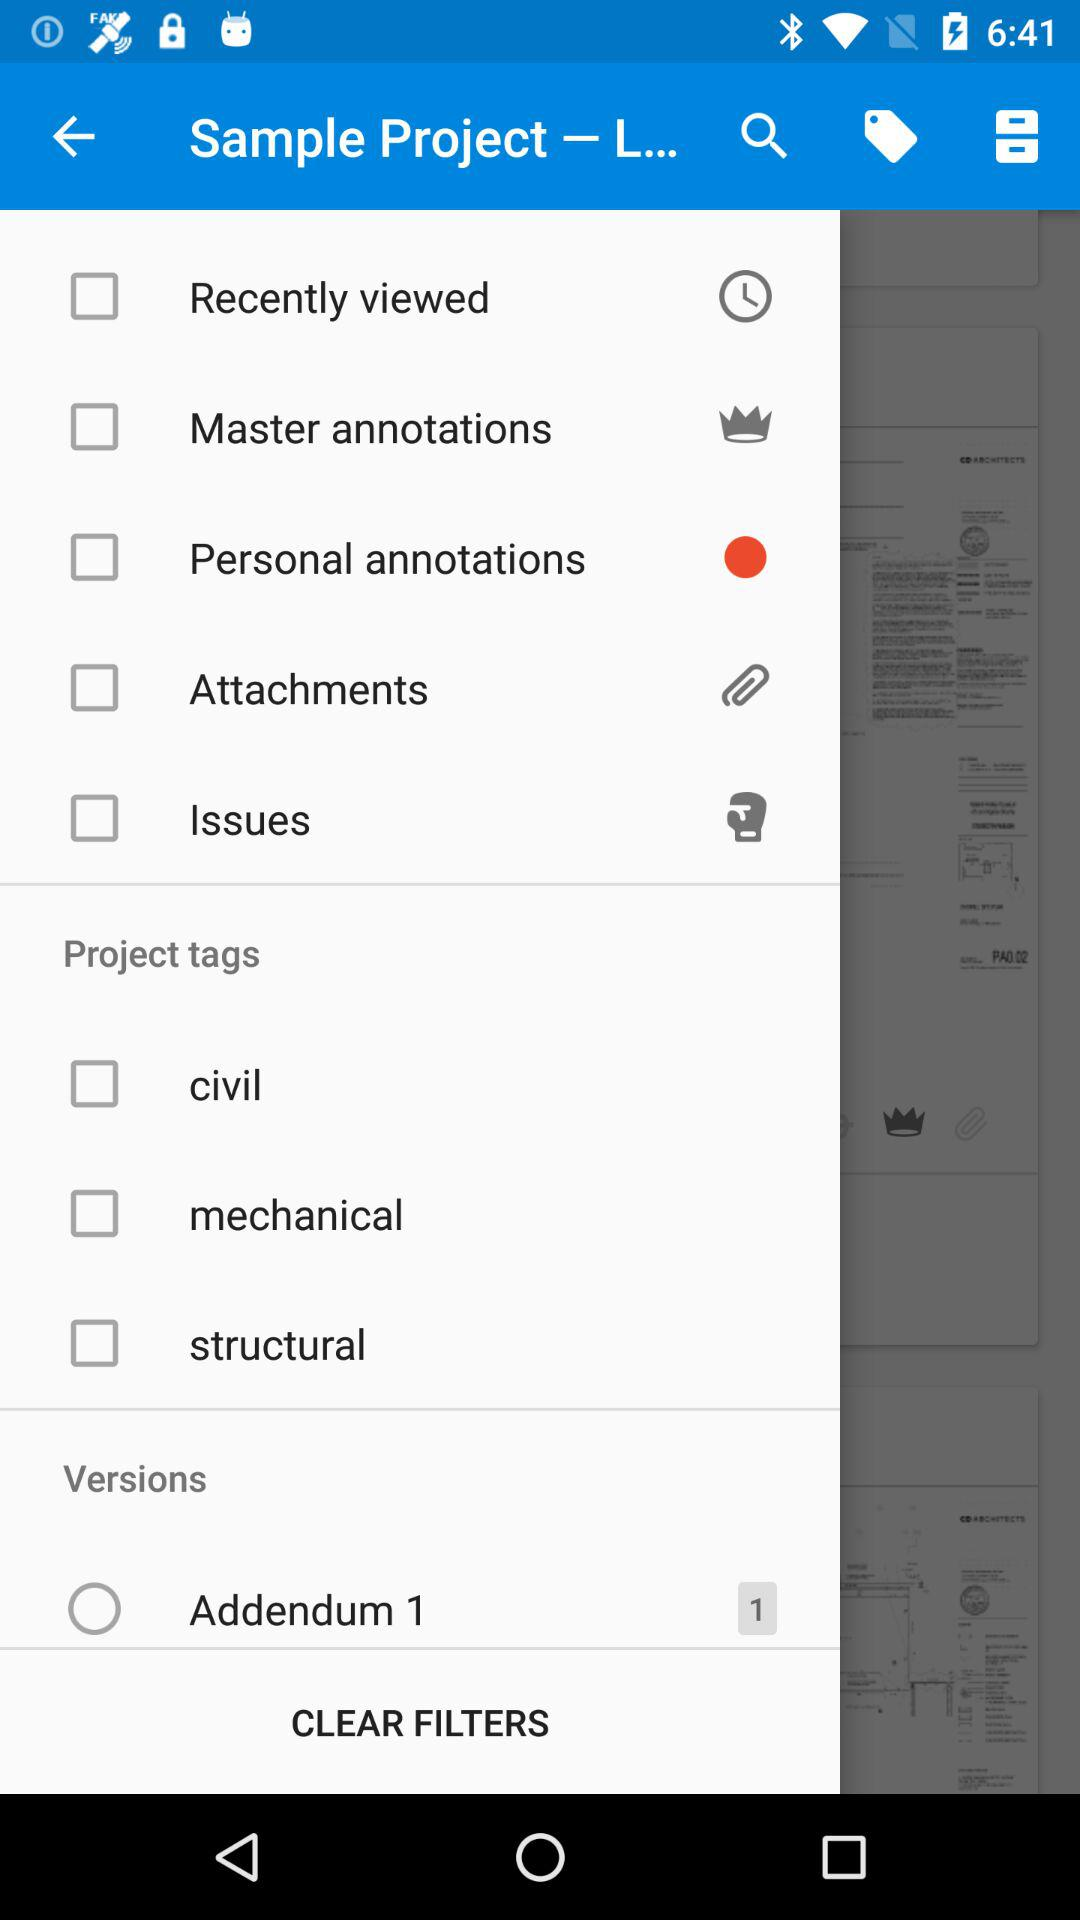What number is shown in "Addendum 1"? The shown number in "Addendum 1" is 1. 